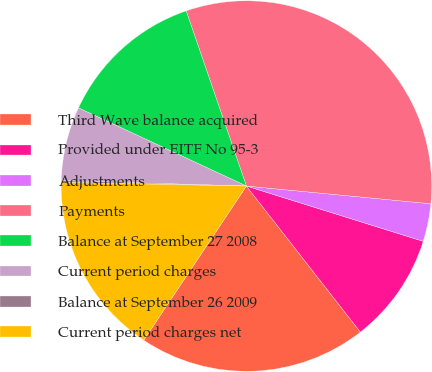Convert chart to OTSL. <chart><loc_0><loc_0><loc_500><loc_500><pie_chart><fcel>Third Wave balance acquired<fcel>Provided under EITF No 95-3<fcel>Adjustments<fcel>Payments<fcel>Balance at September 27 2008<fcel>Current period charges<fcel>Balance at September 26 2009<fcel>Current period charges net<nl><fcel>19.9%<fcel>9.63%<fcel>3.3%<fcel>31.8%<fcel>12.8%<fcel>6.47%<fcel>0.14%<fcel>15.97%<nl></chart> 